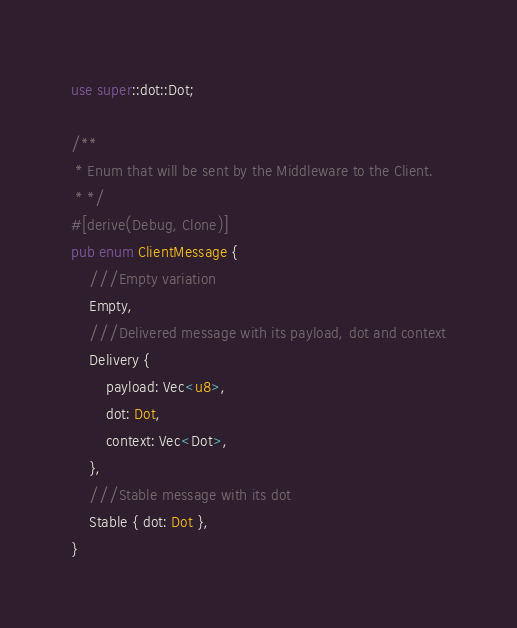Convert code to text. <code><loc_0><loc_0><loc_500><loc_500><_Rust_>use super::dot::Dot;

/**
 * Enum that will be sent by the Middleware to the Client.
 * */
#[derive(Debug, Clone)]
pub enum ClientMessage {
    ///Empty variation
    Empty,
    ///Delivered message with its payload, dot and context
    Delivery {
        payload: Vec<u8>,
        dot: Dot,
        context: Vec<Dot>,
    },
    ///Stable message with its dot
    Stable { dot: Dot },
}
</code> 